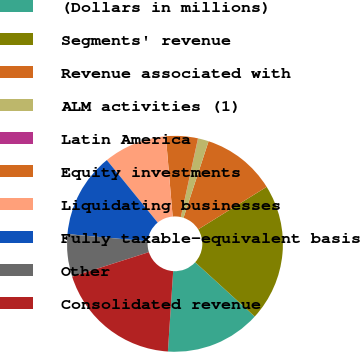<chart> <loc_0><loc_0><loc_500><loc_500><pie_chart><fcel>(Dollars in millions)<fcel>Segments' revenue<fcel>Revenue associated with<fcel>ALM activities (1)<fcel>Latin America<fcel>Equity investments<fcel>Liquidating businesses<fcel>Fully taxable-equivalent basis<fcel>Other<fcel>Consolidated revenue<nl><fcel>14.28%<fcel>20.61%<fcel>11.11%<fcel>1.6%<fcel>0.02%<fcel>4.77%<fcel>9.52%<fcel>12.69%<fcel>6.36%<fcel>19.03%<nl></chart> 